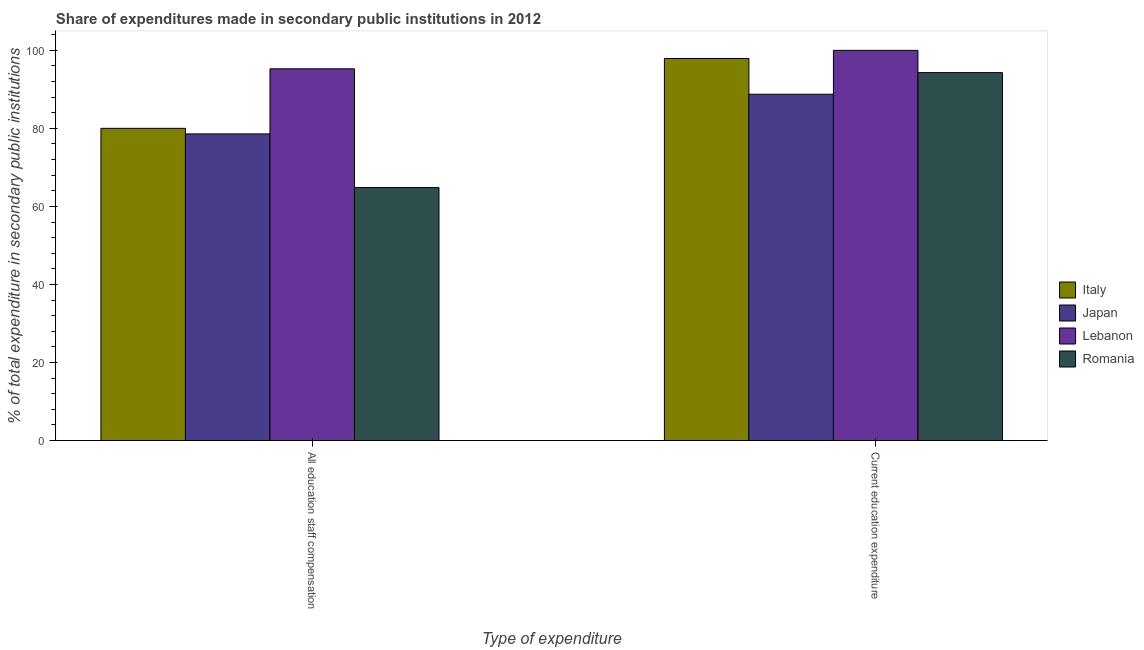How many different coloured bars are there?
Your response must be concise. 4. Are the number of bars on each tick of the X-axis equal?
Provide a succinct answer. Yes. What is the label of the 1st group of bars from the left?
Make the answer very short. All education staff compensation. What is the expenditure in staff compensation in Japan?
Make the answer very short. 78.58. Across all countries, what is the maximum expenditure in education?
Make the answer very short. 100. Across all countries, what is the minimum expenditure in education?
Offer a very short reply. 88.75. In which country was the expenditure in staff compensation maximum?
Your answer should be compact. Lebanon. In which country was the expenditure in staff compensation minimum?
Make the answer very short. Romania. What is the total expenditure in staff compensation in the graph?
Your response must be concise. 318.7. What is the difference between the expenditure in staff compensation in Romania and that in Italy?
Keep it short and to the point. -15.17. What is the difference between the expenditure in staff compensation in Romania and the expenditure in education in Lebanon?
Ensure brevity in your answer.  -35.16. What is the average expenditure in staff compensation per country?
Keep it short and to the point. 79.68. What is the difference between the expenditure in education and expenditure in staff compensation in Lebanon?
Make the answer very short. 4.74. What is the ratio of the expenditure in staff compensation in Italy to that in Romania?
Your response must be concise. 1.23. Is the expenditure in staff compensation in Romania less than that in Lebanon?
Your answer should be very brief. Yes. What does the 2nd bar from the right in All education staff compensation represents?
Keep it short and to the point. Lebanon. How many bars are there?
Make the answer very short. 8. Are all the bars in the graph horizontal?
Provide a short and direct response. No. What is the difference between two consecutive major ticks on the Y-axis?
Offer a terse response. 20. Where does the legend appear in the graph?
Your answer should be very brief. Center right. How many legend labels are there?
Your response must be concise. 4. What is the title of the graph?
Give a very brief answer. Share of expenditures made in secondary public institutions in 2012. Does "Ghana" appear as one of the legend labels in the graph?
Ensure brevity in your answer.  No. What is the label or title of the X-axis?
Keep it short and to the point. Type of expenditure. What is the label or title of the Y-axis?
Ensure brevity in your answer.  % of total expenditure in secondary public institutions. What is the % of total expenditure in secondary public institutions of Italy in All education staff compensation?
Your response must be concise. 80.01. What is the % of total expenditure in secondary public institutions in Japan in All education staff compensation?
Ensure brevity in your answer.  78.58. What is the % of total expenditure in secondary public institutions in Lebanon in All education staff compensation?
Offer a terse response. 95.26. What is the % of total expenditure in secondary public institutions of Romania in All education staff compensation?
Provide a succinct answer. 64.84. What is the % of total expenditure in secondary public institutions of Italy in Current education expenditure?
Your answer should be very brief. 97.91. What is the % of total expenditure in secondary public institutions of Japan in Current education expenditure?
Provide a short and direct response. 88.75. What is the % of total expenditure in secondary public institutions in Lebanon in Current education expenditure?
Provide a short and direct response. 100. What is the % of total expenditure in secondary public institutions of Romania in Current education expenditure?
Ensure brevity in your answer.  94.29. Across all Type of expenditure, what is the maximum % of total expenditure in secondary public institutions of Italy?
Keep it short and to the point. 97.91. Across all Type of expenditure, what is the maximum % of total expenditure in secondary public institutions of Japan?
Offer a terse response. 88.75. Across all Type of expenditure, what is the maximum % of total expenditure in secondary public institutions in Romania?
Give a very brief answer. 94.29. Across all Type of expenditure, what is the minimum % of total expenditure in secondary public institutions of Italy?
Give a very brief answer. 80.01. Across all Type of expenditure, what is the minimum % of total expenditure in secondary public institutions in Japan?
Your answer should be compact. 78.58. Across all Type of expenditure, what is the minimum % of total expenditure in secondary public institutions in Lebanon?
Offer a terse response. 95.26. Across all Type of expenditure, what is the minimum % of total expenditure in secondary public institutions in Romania?
Your answer should be compact. 64.84. What is the total % of total expenditure in secondary public institutions of Italy in the graph?
Ensure brevity in your answer.  177.93. What is the total % of total expenditure in secondary public institutions in Japan in the graph?
Your answer should be very brief. 167.34. What is the total % of total expenditure in secondary public institutions of Lebanon in the graph?
Your answer should be very brief. 195.26. What is the total % of total expenditure in secondary public institutions of Romania in the graph?
Your response must be concise. 159.13. What is the difference between the % of total expenditure in secondary public institutions in Italy in All education staff compensation and that in Current education expenditure?
Ensure brevity in your answer.  -17.9. What is the difference between the % of total expenditure in secondary public institutions in Japan in All education staff compensation and that in Current education expenditure?
Provide a succinct answer. -10.17. What is the difference between the % of total expenditure in secondary public institutions in Lebanon in All education staff compensation and that in Current education expenditure?
Offer a very short reply. -4.74. What is the difference between the % of total expenditure in secondary public institutions of Romania in All education staff compensation and that in Current education expenditure?
Provide a short and direct response. -29.45. What is the difference between the % of total expenditure in secondary public institutions of Italy in All education staff compensation and the % of total expenditure in secondary public institutions of Japan in Current education expenditure?
Offer a very short reply. -8.74. What is the difference between the % of total expenditure in secondary public institutions of Italy in All education staff compensation and the % of total expenditure in secondary public institutions of Lebanon in Current education expenditure?
Your answer should be compact. -19.99. What is the difference between the % of total expenditure in secondary public institutions in Italy in All education staff compensation and the % of total expenditure in secondary public institutions in Romania in Current education expenditure?
Give a very brief answer. -14.28. What is the difference between the % of total expenditure in secondary public institutions in Japan in All education staff compensation and the % of total expenditure in secondary public institutions in Lebanon in Current education expenditure?
Offer a very short reply. -21.42. What is the difference between the % of total expenditure in secondary public institutions of Japan in All education staff compensation and the % of total expenditure in secondary public institutions of Romania in Current education expenditure?
Offer a very short reply. -15.71. What is the difference between the % of total expenditure in secondary public institutions of Lebanon in All education staff compensation and the % of total expenditure in secondary public institutions of Romania in Current education expenditure?
Your answer should be compact. 0.97. What is the average % of total expenditure in secondary public institutions in Italy per Type of expenditure?
Your answer should be very brief. 88.96. What is the average % of total expenditure in secondary public institutions of Japan per Type of expenditure?
Make the answer very short. 83.67. What is the average % of total expenditure in secondary public institutions in Lebanon per Type of expenditure?
Your response must be concise. 97.63. What is the average % of total expenditure in secondary public institutions in Romania per Type of expenditure?
Make the answer very short. 79.57. What is the difference between the % of total expenditure in secondary public institutions in Italy and % of total expenditure in secondary public institutions in Japan in All education staff compensation?
Keep it short and to the point. 1.43. What is the difference between the % of total expenditure in secondary public institutions of Italy and % of total expenditure in secondary public institutions of Lebanon in All education staff compensation?
Provide a succinct answer. -15.25. What is the difference between the % of total expenditure in secondary public institutions of Italy and % of total expenditure in secondary public institutions of Romania in All education staff compensation?
Give a very brief answer. 15.17. What is the difference between the % of total expenditure in secondary public institutions in Japan and % of total expenditure in secondary public institutions in Lebanon in All education staff compensation?
Your answer should be very brief. -16.68. What is the difference between the % of total expenditure in secondary public institutions of Japan and % of total expenditure in secondary public institutions of Romania in All education staff compensation?
Provide a succinct answer. 13.74. What is the difference between the % of total expenditure in secondary public institutions in Lebanon and % of total expenditure in secondary public institutions in Romania in All education staff compensation?
Offer a terse response. 30.42. What is the difference between the % of total expenditure in secondary public institutions in Italy and % of total expenditure in secondary public institutions in Japan in Current education expenditure?
Offer a very short reply. 9.16. What is the difference between the % of total expenditure in secondary public institutions of Italy and % of total expenditure in secondary public institutions of Lebanon in Current education expenditure?
Ensure brevity in your answer.  -2.09. What is the difference between the % of total expenditure in secondary public institutions in Italy and % of total expenditure in secondary public institutions in Romania in Current education expenditure?
Your response must be concise. 3.62. What is the difference between the % of total expenditure in secondary public institutions of Japan and % of total expenditure in secondary public institutions of Lebanon in Current education expenditure?
Your answer should be very brief. -11.25. What is the difference between the % of total expenditure in secondary public institutions in Japan and % of total expenditure in secondary public institutions in Romania in Current education expenditure?
Provide a succinct answer. -5.54. What is the difference between the % of total expenditure in secondary public institutions of Lebanon and % of total expenditure in secondary public institutions of Romania in Current education expenditure?
Offer a terse response. 5.71. What is the ratio of the % of total expenditure in secondary public institutions in Italy in All education staff compensation to that in Current education expenditure?
Ensure brevity in your answer.  0.82. What is the ratio of the % of total expenditure in secondary public institutions in Japan in All education staff compensation to that in Current education expenditure?
Keep it short and to the point. 0.89. What is the ratio of the % of total expenditure in secondary public institutions of Lebanon in All education staff compensation to that in Current education expenditure?
Provide a succinct answer. 0.95. What is the ratio of the % of total expenditure in secondary public institutions of Romania in All education staff compensation to that in Current education expenditure?
Keep it short and to the point. 0.69. What is the difference between the highest and the second highest % of total expenditure in secondary public institutions in Italy?
Make the answer very short. 17.9. What is the difference between the highest and the second highest % of total expenditure in secondary public institutions of Japan?
Provide a short and direct response. 10.17. What is the difference between the highest and the second highest % of total expenditure in secondary public institutions of Lebanon?
Ensure brevity in your answer.  4.74. What is the difference between the highest and the second highest % of total expenditure in secondary public institutions of Romania?
Provide a succinct answer. 29.45. What is the difference between the highest and the lowest % of total expenditure in secondary public institutions in Italy?
Make the answer very short. 17.9. What is the difference between the highest and the lowest % of total expenditure in secondary public institutions in Japan?
Provide a short and direct response. 10.17. What is the difference between the highest and the lowest % of total expenditure in secondary public institutions of Lebanon?
Your answer should be very brief. 4.74. What is the difference between the highest and the lowest % of total expenditure in secondary public institutions in Romania?
Your answer should be very brief. 29.45. 